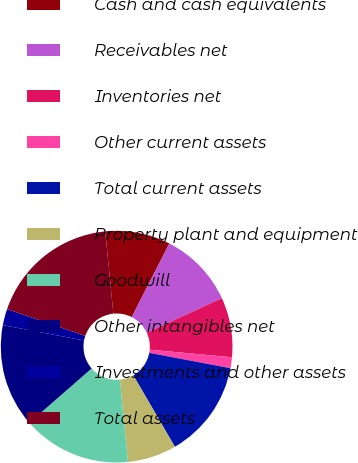<chart> <loc_0><loc_0><loc_500><loc_500><pie_chart><fcel>Cash and cash equivalents<fcel>Receivables net<fcel>Inventories net<fcel>Other current assets<fcel>Total current assets<fcel>Property plant and equipment<fcel>Goodwill<fcel>Other intangibles net<fcel>Investments and other assets<fcel>Total assets<nl><fcel>9.09%<fcel>10.61%<fcel>8.33%<fcel>1.52%<fcel>13.64%<fcel>6.82%<fcel>15.15%<fcel>14.39%<fcel>2.27%<fcel>18.18%<nl></chart> 